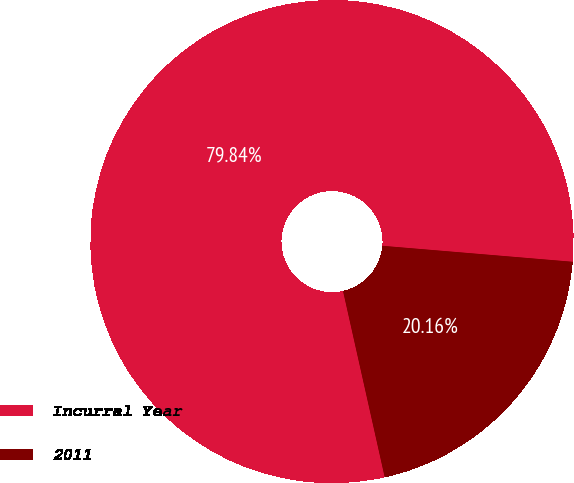Convert chart to OTSL. <chart><loc_0><loc_0><loc_500><loc_500><pie_chart><fcel>Incurral Year<fcel>2011<nl><fcel>79.84%<fcel>20.16%<nl></chart> 